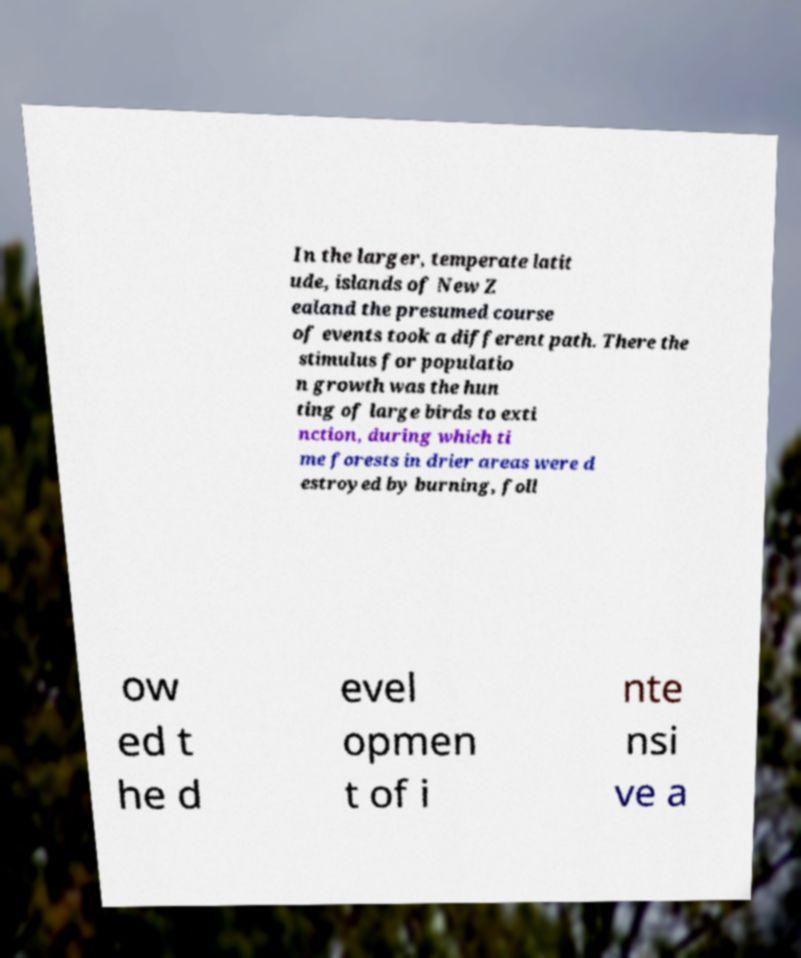I need the written content from this picture converted into text. Can you do that? In the larger, temperate latit ude, islands of New Z ealand the presumed course of events took a different path. There the stimulus for populatio n growth was the hun ting of large birds to exti nction, during which ti me forests in drier areas were d estroyed by burning, foll ow ed t he d evel opmen t of i nte nsi ve a 